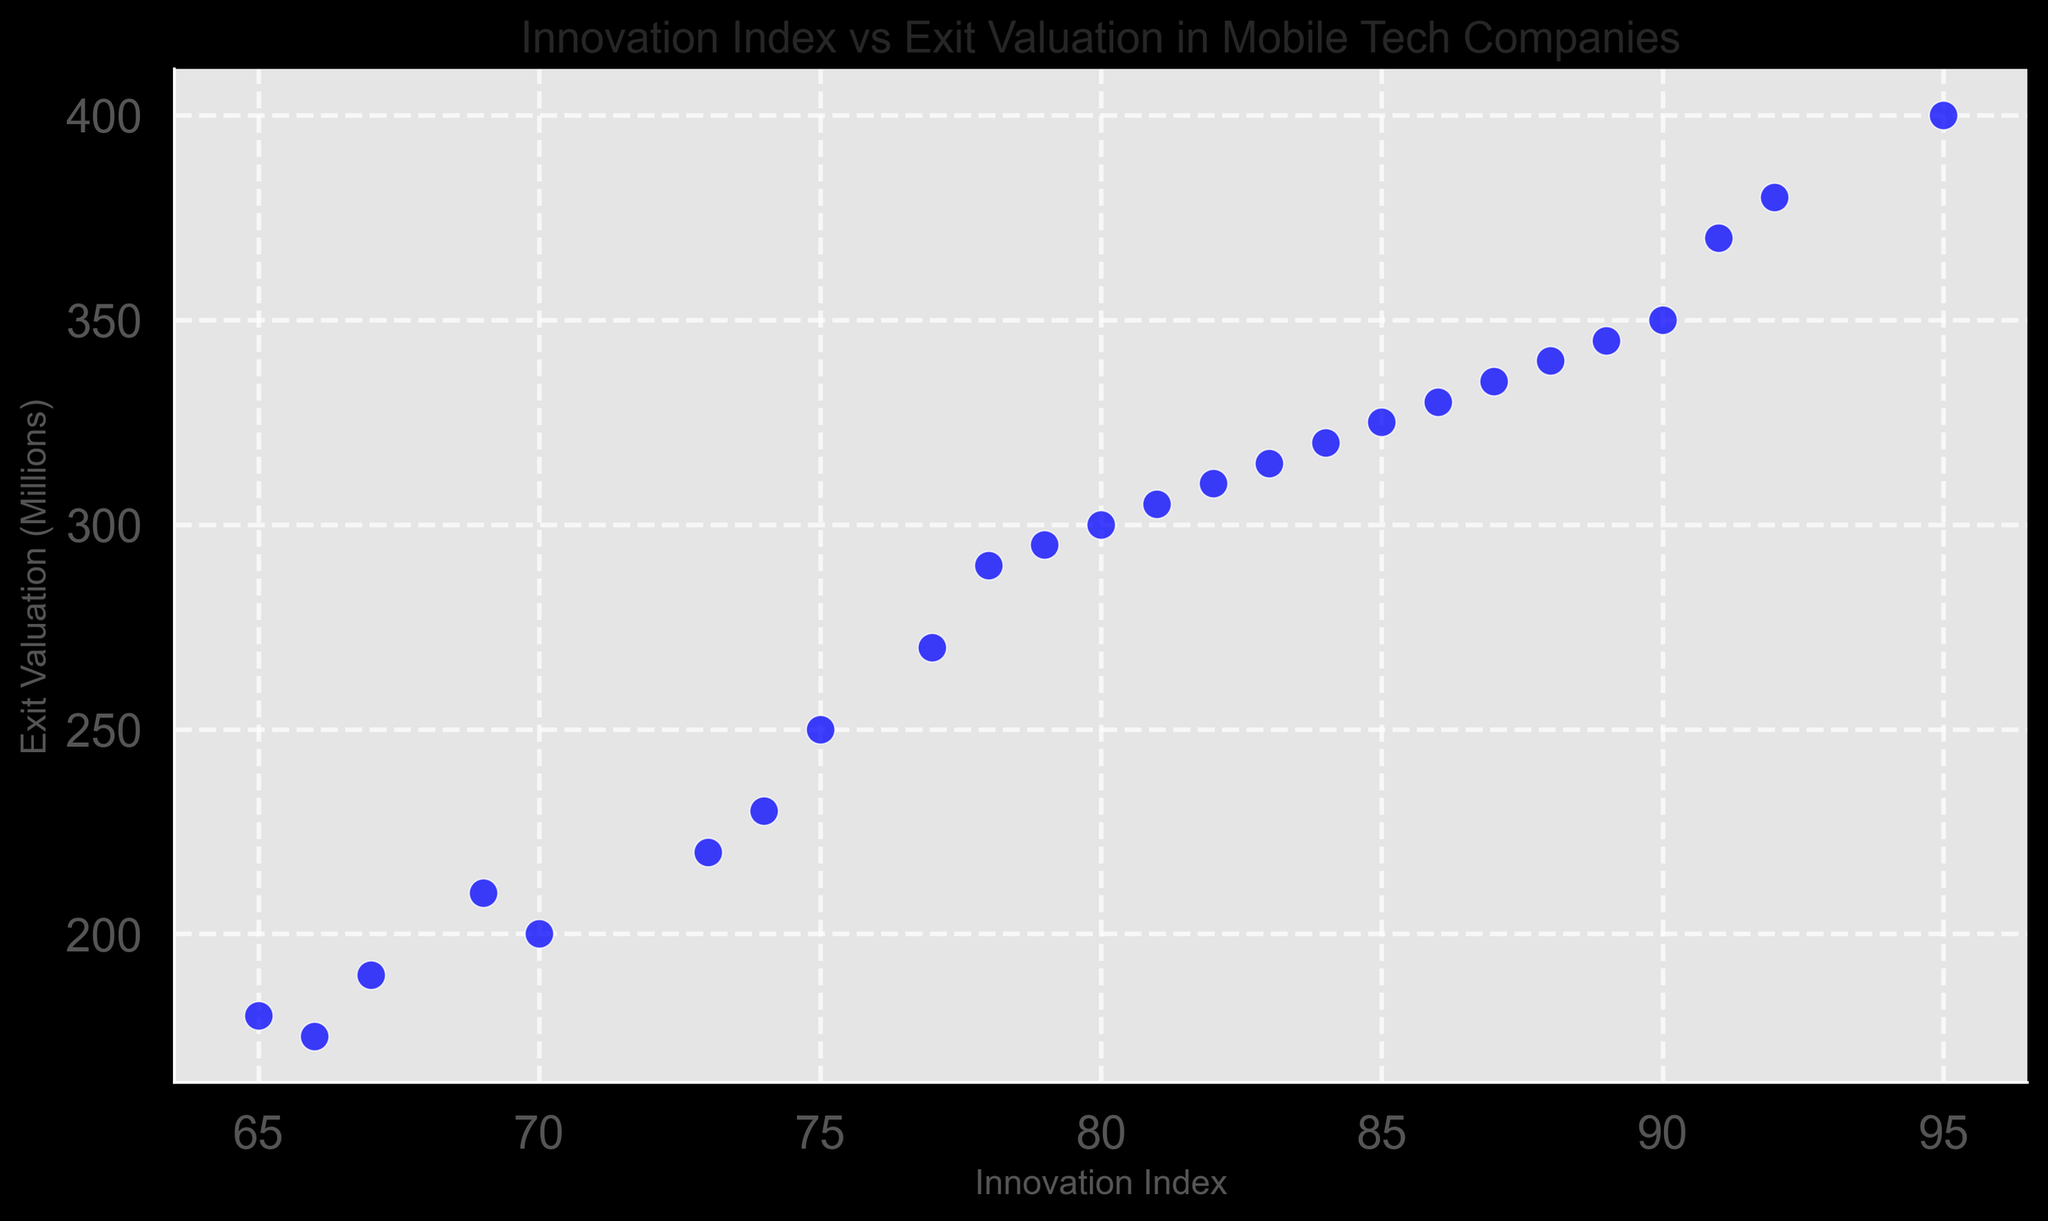What is the general trend observed between Innovation Index and Exit Valuation? The trend on the scatter plot shows that as the Innovation Index increases, the Exit Valuation also tends to increase. This indicates a positive correlation between the two variables.
Answer: A positive correlation Which data point has the highest Exit Valuation and what is its corresponding Innovation Index? On the scatter plot, the highest Exit Valuation is represented by the top-most data point. The Exit Valuation is 400 million and its corresponding Innovation Index is 95.
Answer: 400 million, 95 Is there any data point with the same Innovation Index but a different Exit Valuation? By examining the scatter plot, we can see that no two points share the same Innovation Index value, so each Innovation Index corresponds to a unique Exit Valuation.
Answer: No What is the range of the Exit Valuation values? The minimum Exit Valuation visible on the scatter plot is 175 million and the maximum is 400 million. The range is calculated as 400 - 175.
Answer: 225 million Which data point deviates the most from the general trend? The point with an Innovation Index of 65 and an Exit Valuation of 180 million appears to be the most below the trend line compared to other points, indicating it deviates the most from the general trend.
Answer: 65, 180 million What is the average Exit Valuation for companies with an Innovation Index above 80? By collecting the Exit Valuation values for Innovation Indexes above 80 (300, 350, 325, 400, 340, 310, 380, 305, 370, 335, 330), summing them gives 4,045 million. There are 11 data points, so the average is 4045 / 11.
Answer: 367.27 million Compare the Exit Valuation of companies with an Innovation Index of 70 and 90. Which has a higher Exit Valuation? The scatter plot shows that the company with an Innovation Index of 70 has an Exit Valuation of 200 million, while the company with an Innovation Index of 90 has an Exit Valuation of 350 million.
Answer: 90 How many companies have an Exit Valuation greater than 300 million? By counting the data points above the 300 million mark on the Exit Valuation axis, there are 9 companies with an Exit Valuation greater than 300 million.
Answer: 9 What is the difference in Exit Valuation between the companies with the highest and lowest Innovation Index? The highest Innovation Index is 95 with an Exit Valuation of 400 million, and the lowest Innovation Index is 65 with an Exit Valuation of 180 million. The difference is 400 - 180 million.
Answer: 220 million Is there any noticeable clustering or grouping in the scatter plot? The scatter plot shows a fairly continuous distribution of points, but a slight denser clustering around the middle range of Innovation Index values (75 to 85), with corresponding Exit Valuations mostly between 250 and 330 million.
Answer: Slight clustering around 75-85 Innovation Index 